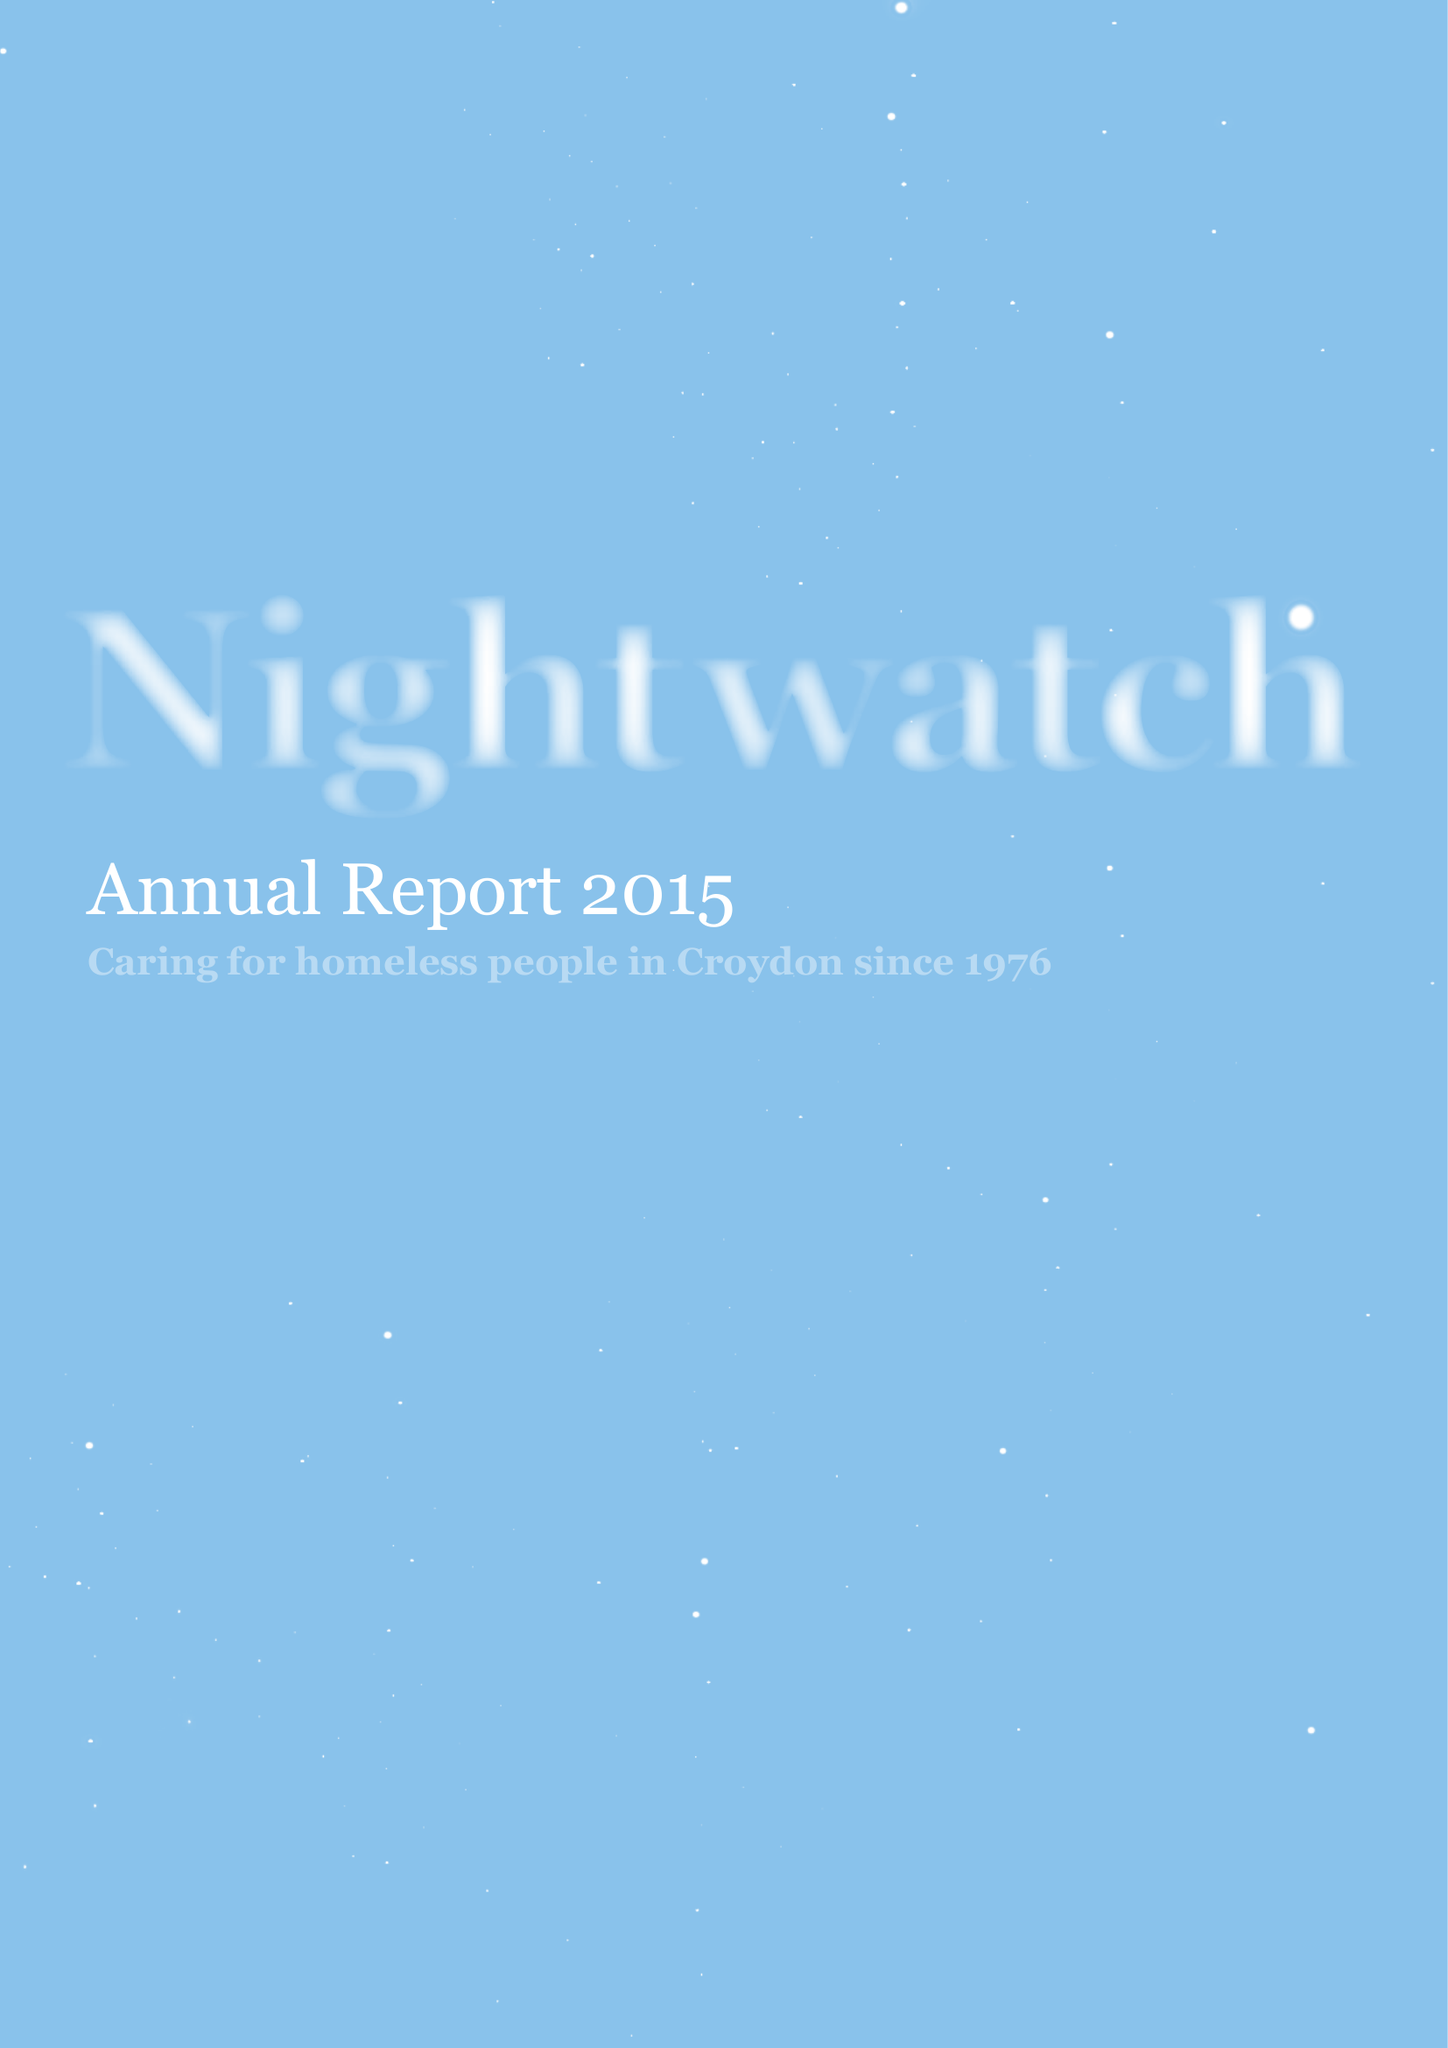What is the value for the report_date?
Answer the question using a single word or phrase. 2014-12-31 